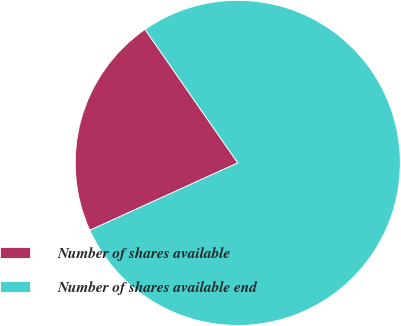Convert chart. <chart><loc_0><loc_0><loc_500><loc_500><pie_chart><fcel>Number of shares available<fcel>Number of shares available end<nl><fcel>22.14%<fcel>77.86%<nl></chart> 